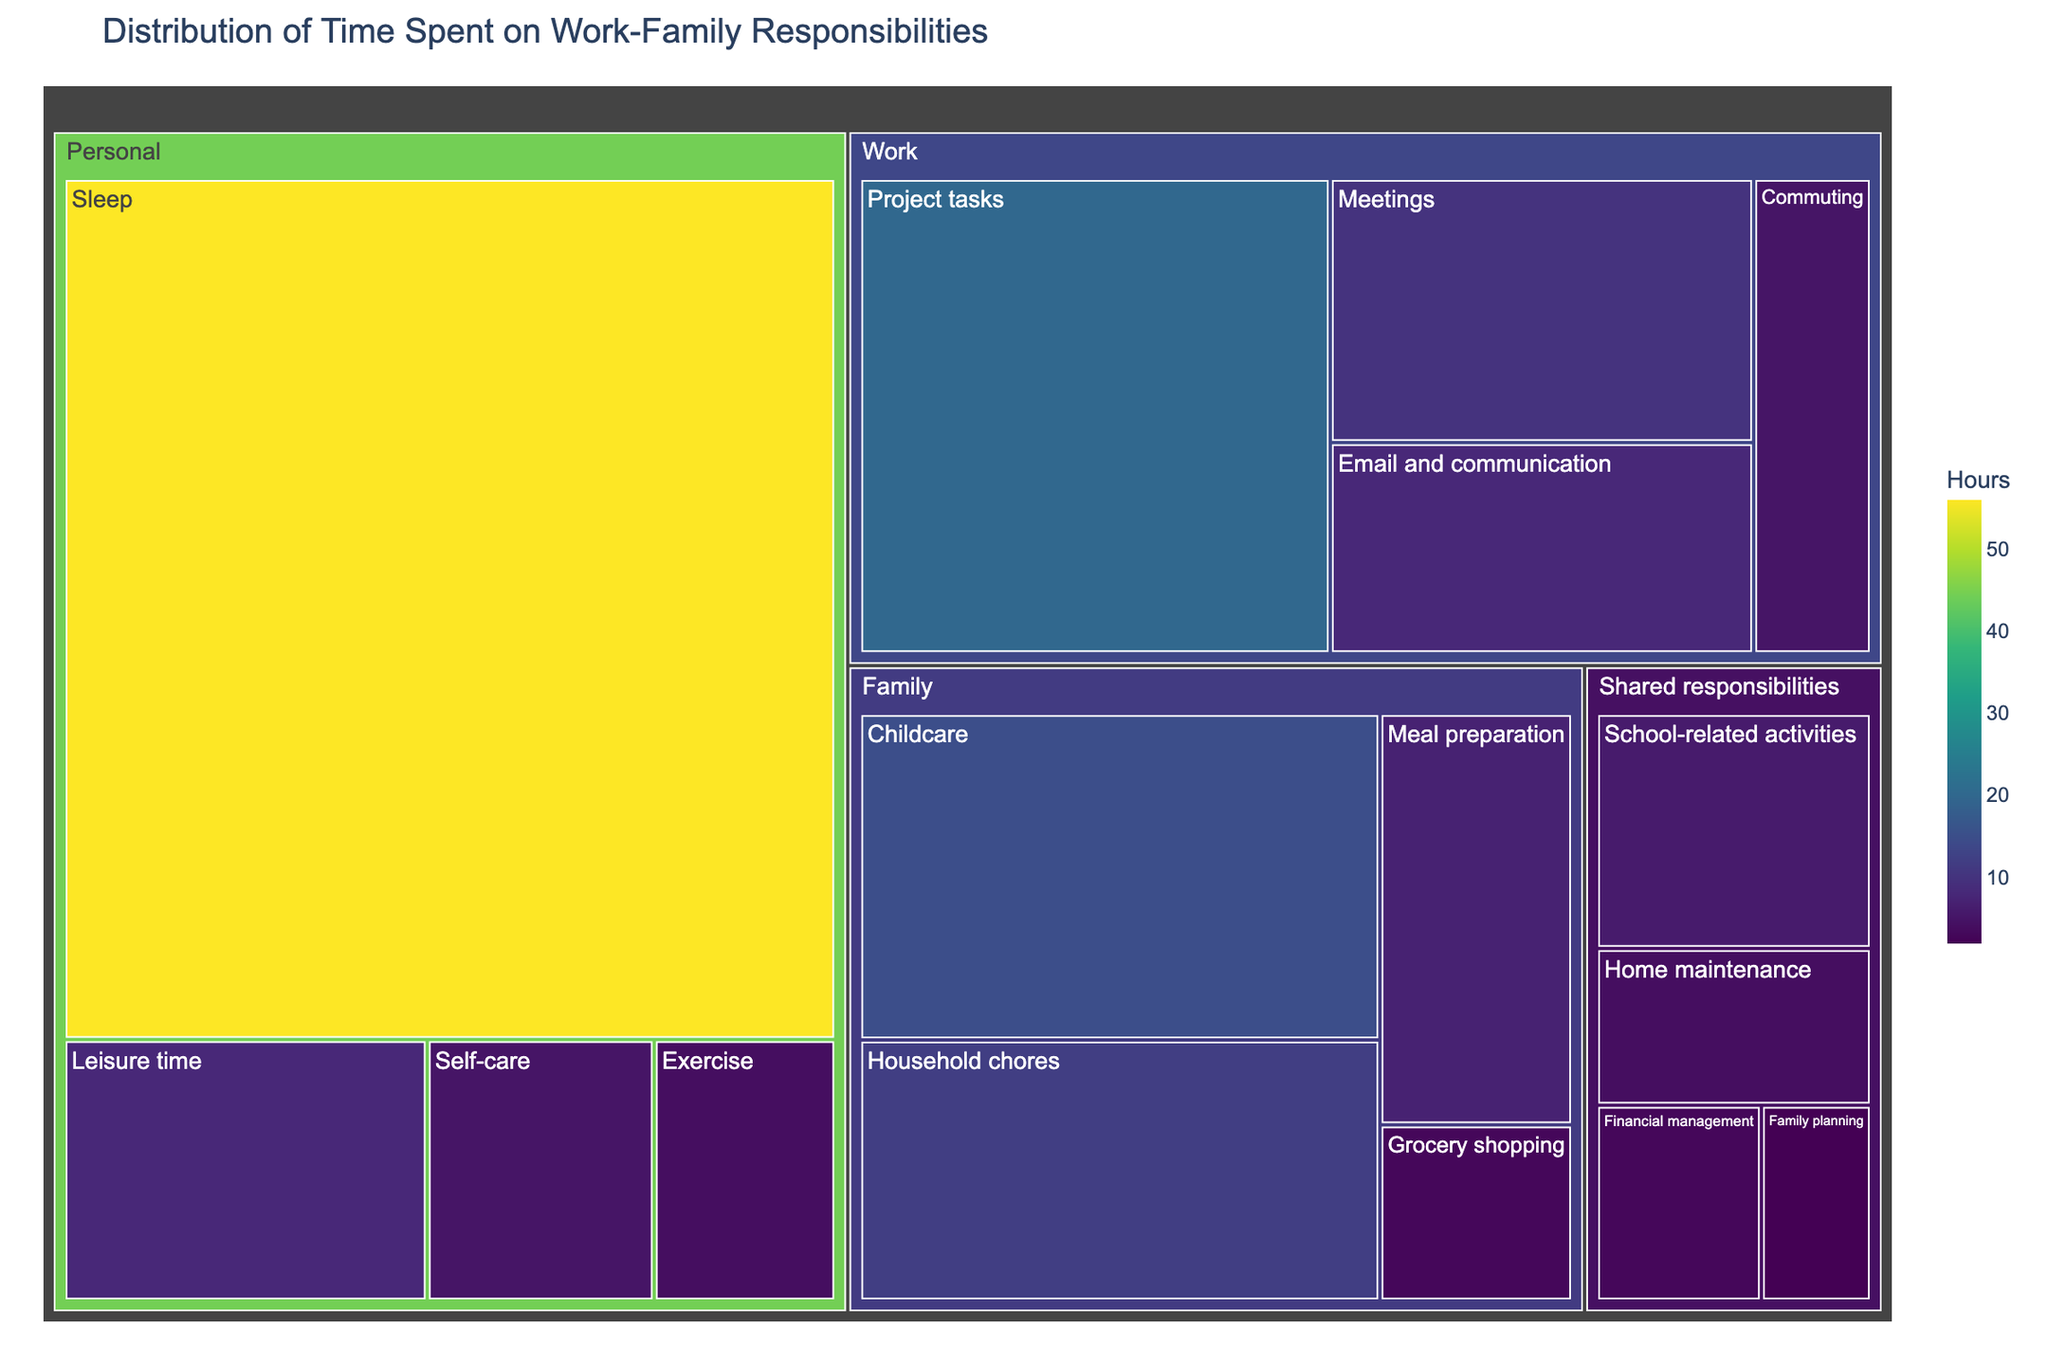what is the title of the treemap? The title of the treemap is usually displayed at the top of the figure. By referring to the text in that position, we can see what the title states.
Answer: Distribution of Time Spent on Work-Family Responsibilities Which category has the most hours spent overall? By visually comparing the size of the sections within each category, we can identify the largest section which represents the category with the highest total hours spent.
Answer: Personal What is the total time spent on Work-related tasks? Sum the hours of all subcategories under the "Work" category: Meetings (10) + Project tasks (20) + Email and communication (8) + Commuting (5) = 10 + 20 + 8 + 5
Answer: 43 hours Which subcategory has the highest number of hours? By observing the size and color (darkest shade) of the segments within all categories in the treemap, the subcategory with the highest value can be identified. The segment for "Sleep" under "Personal" is the largest and darkest.
Answer: Sleep What is the difference in hours between "Household chores" and "Commuting"? Compare the hours for "Household chores" (12) and "Commuting" (5) and subtract the smaller value from the larger one: 12 - 5 = 7
Answer: 7 hours How many hours are spent on Shared responsibilities in total? Sum the hours of all subcategories under "Shared responsibilities": Family planning (2) + Financial management (3) + Home maintenance (4) + School-related activities (6) = 2 + 3 + 4 + 6
Answer: 15 hours Which category has the highest variety of tasks? Count the number of different subcategories within each category. "Family" has the most subcategories (Childcare, Household chores, Grocery shopping, Meal preparation).
Answer: Family What is the sum of hours spent on "Family" and "Shared responsibilities"? Add the total hours spent on "Family" to the total hours spent on "Shared responsibilities": Family (15 + 12 + 3 + 7) + Shared responsibilities (2 + 3 + 4 + 6) = 37 + 15 = 52 hours
Answer: 52 hours Which subcategories in the "Personal" category have fewer hours than "Leisure time"? Compare the hours of each subcategory within "Personal" to "Leisure time" (8): Sleep (56), Exercise (4), Leisure time (8), Self-care (5). "Exercise" and "Self-care" are less than 8 hours.
Answer: Exercise, Self-care Is more time spent on Meal preparation than on Exercise? Compare the hours spent on "Meal preparation" (7) to the hours spent on "Exercise" (4). Since 7 is greater than 4, we can conclude.
Answer: Yes 